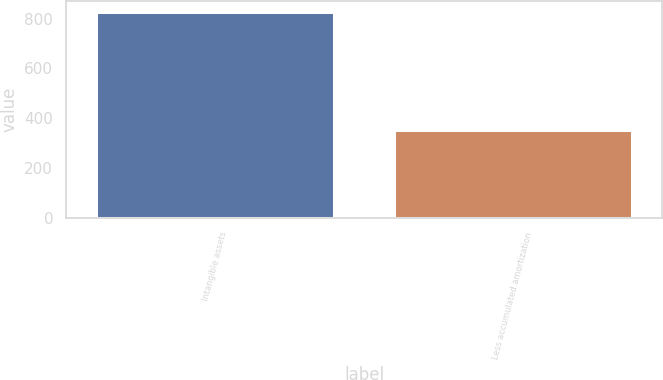Convert chart. <chart><loc_0><loc_0><loc_500><loc_500><bar_chart><fcel>Intangible assets<fcel>Less accumulated amortization<nl><fcel>828<fcel>351<nl></chart> 